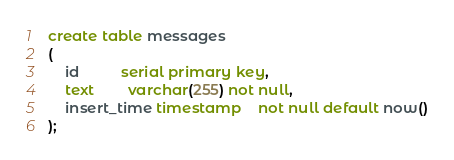Convert code to text. <code><loc_0><loc_0><loc_500><loc_500><_SQL_>create table messages
(
    id          serial primary key,
    text        varchar(255) not null,
    insert_time timestamp    not null default now()
);</code> 